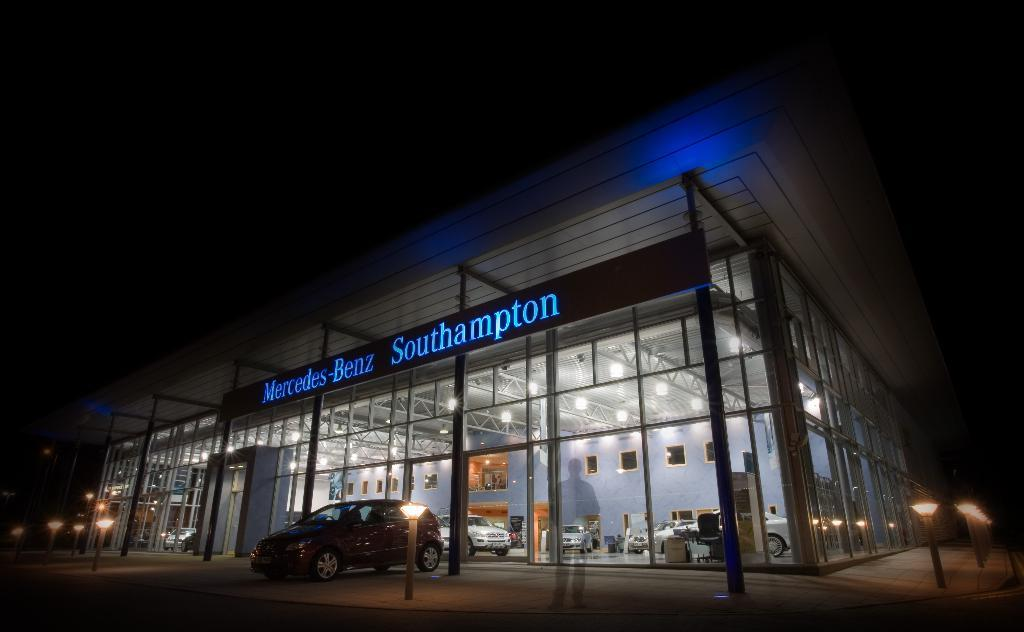What type of establishment is depicted in the image? The image is of a vehicle showroom. What can be found inside the showroom? There are vehicles inside the showroom. What is located in front of the showroom? There are light poles in front of the showroom. Can you identify any human presence in the image? Yes, there is a reflection of a person in the image. How would you describe the lighting conditions in the image? The sky is dark in the image. What type of mine is being used for the distribution of vehicles in the image? There is no mine present in the image, and vehicles are not being distributed; they are displayed in a showroom. 